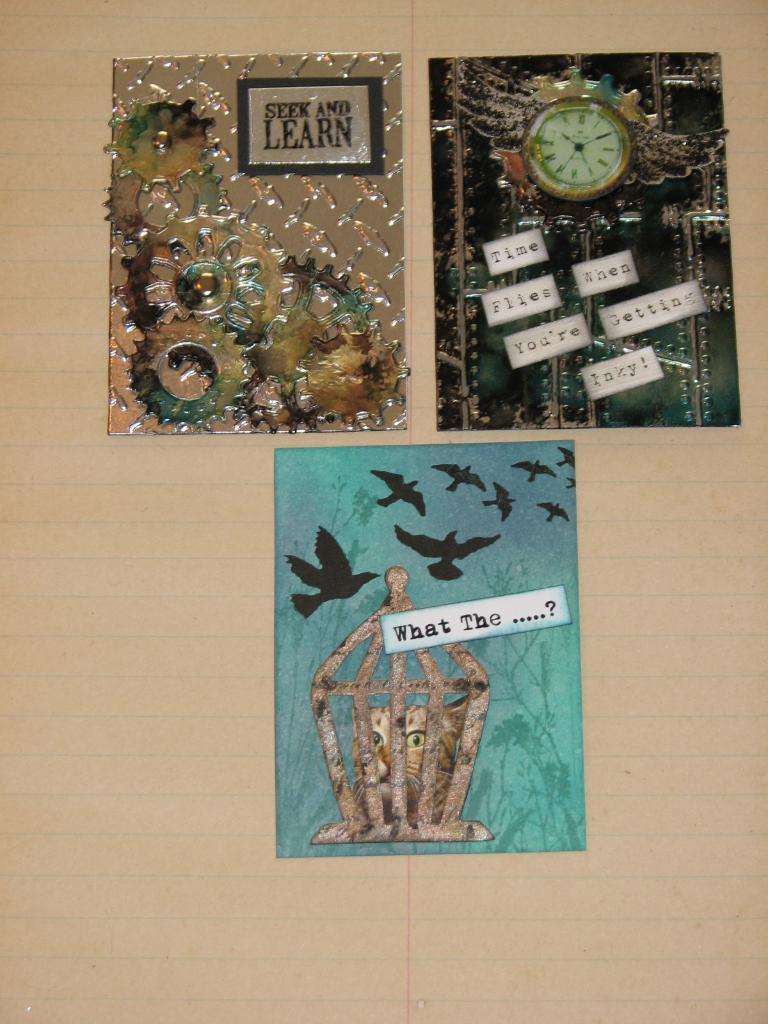What should you do as well as seek according to the image?
Your answer should be very brief. Learn. Are there 9 black birds in the bottom image?
Offer a terse response. Answering does not require reading text in the image. 